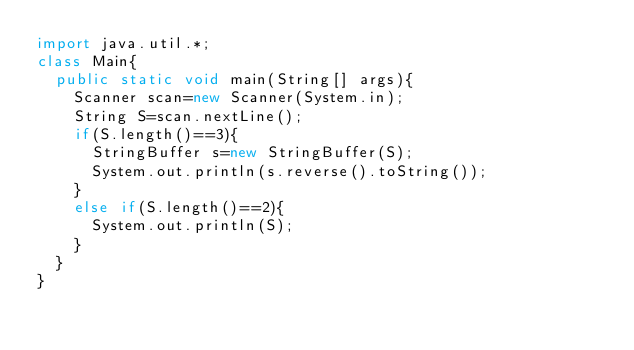Convert code to text. <code><loc_0><loc_0><loc_500><loc_500><_Java_>import java.util.*;
class Main{
  public static void main(String[] args){
    Scanner scan=new Scanner(System.in);
    String S=scan.nextLine();
    if(S.length()==3){
      StringBuffer s=new StringBuffer(S);
      System.out.println(s.reverse().toString());
    }
    else if(S.length()==2){
      System.out.println(S);
    }
  }
}</code> 